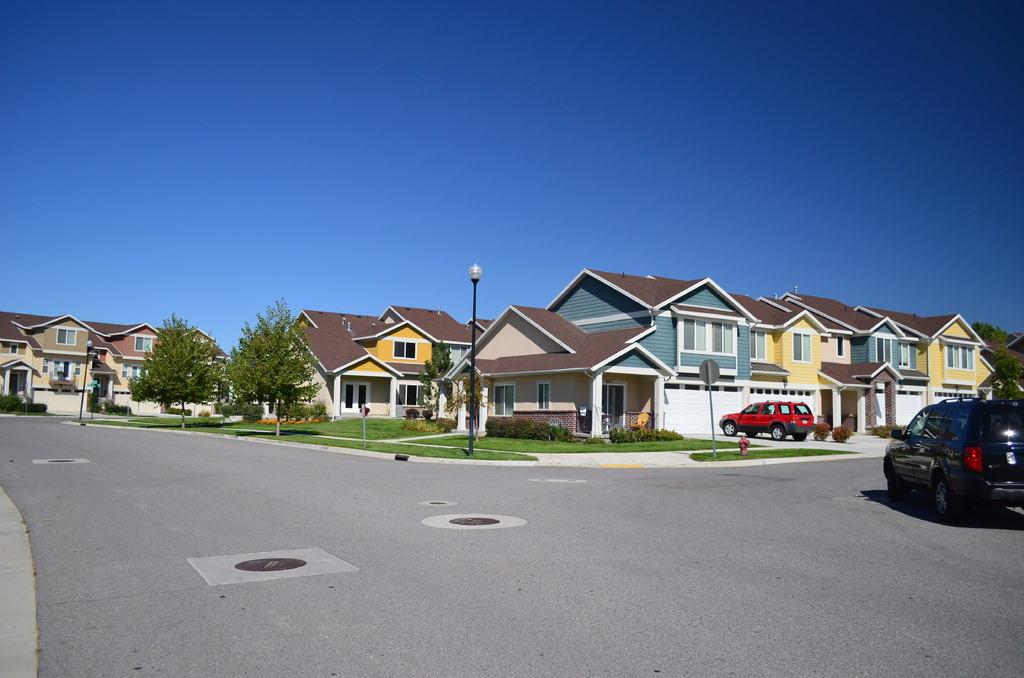What type of structures can be seen in the image? There are colorful shed houses in the image. What natural elements are present in the image? There are trees in the image. What man-made feature is visible in the image? There is a road in the image. What is happening on the road in the image? A black color car is moving on the road. What type of yak can be seen grazing in the lunchroom in the image? There is no yak or lunchroom present in the image; it features colorful shed houses, trees, a road, and a moving car. 